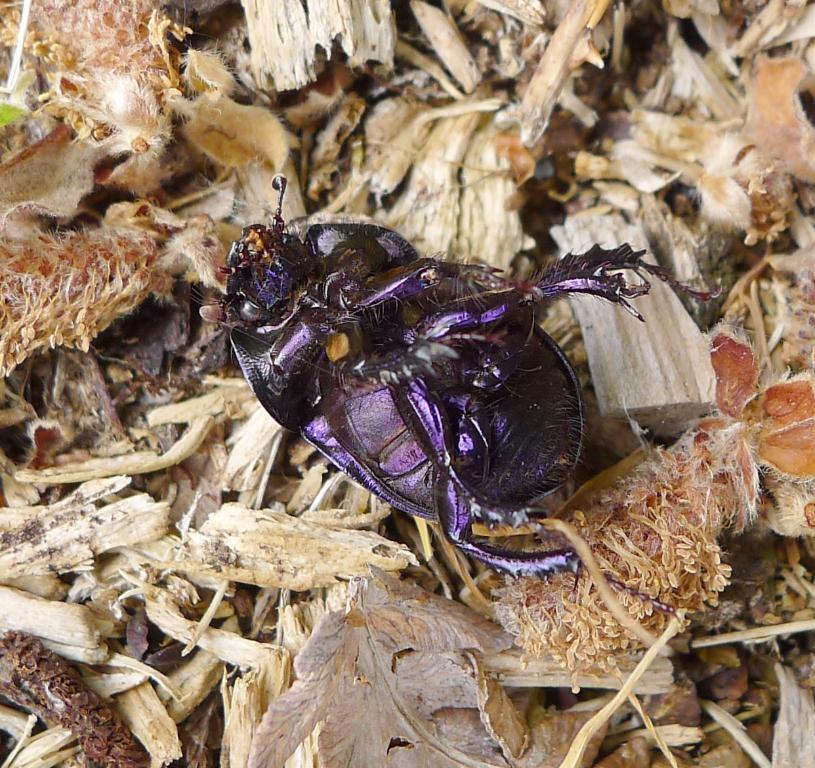What type of creature can be seen in the image? There is an insect in the image. What is covering the ground in the image? The ground is covered with pieces of wood. What type of canvas is the scarecrow holding in the image? There is no canvas or scarecrow present in the image; it only features an insect and pieces of wood on the ground. 